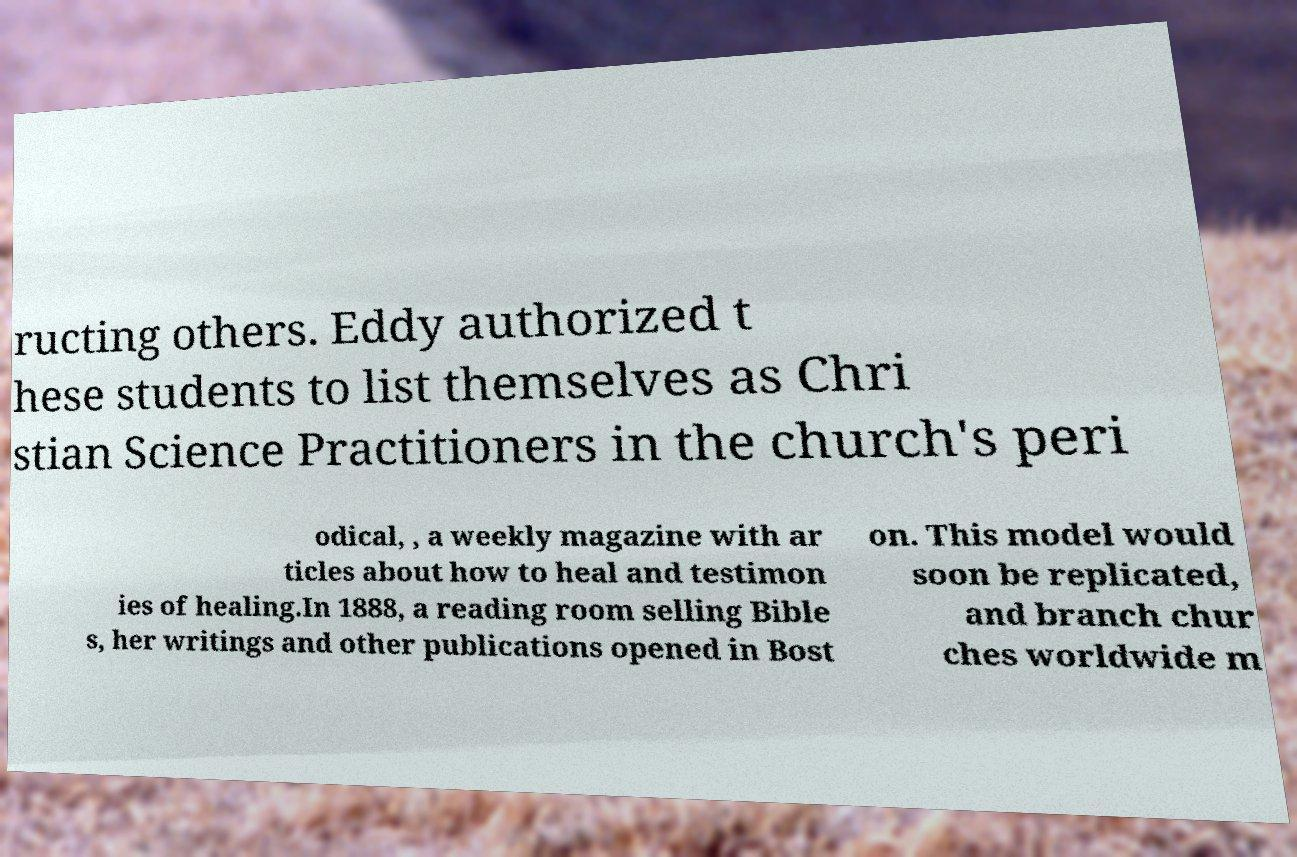Could you assist in decoding the text presented in this image and type it out clearly? ructing others. Eddy authorized t hese students to list themselves as Chri stian Science Practitioners in the church's peri odical, , a weekly magazine with ar ticles about how to heal and testimon ies of healing.In 1888, a reading room selling Bible s, her writings and other publications opened in Bost on. This model would soon be replicated, and branch chur ches worldwide m 